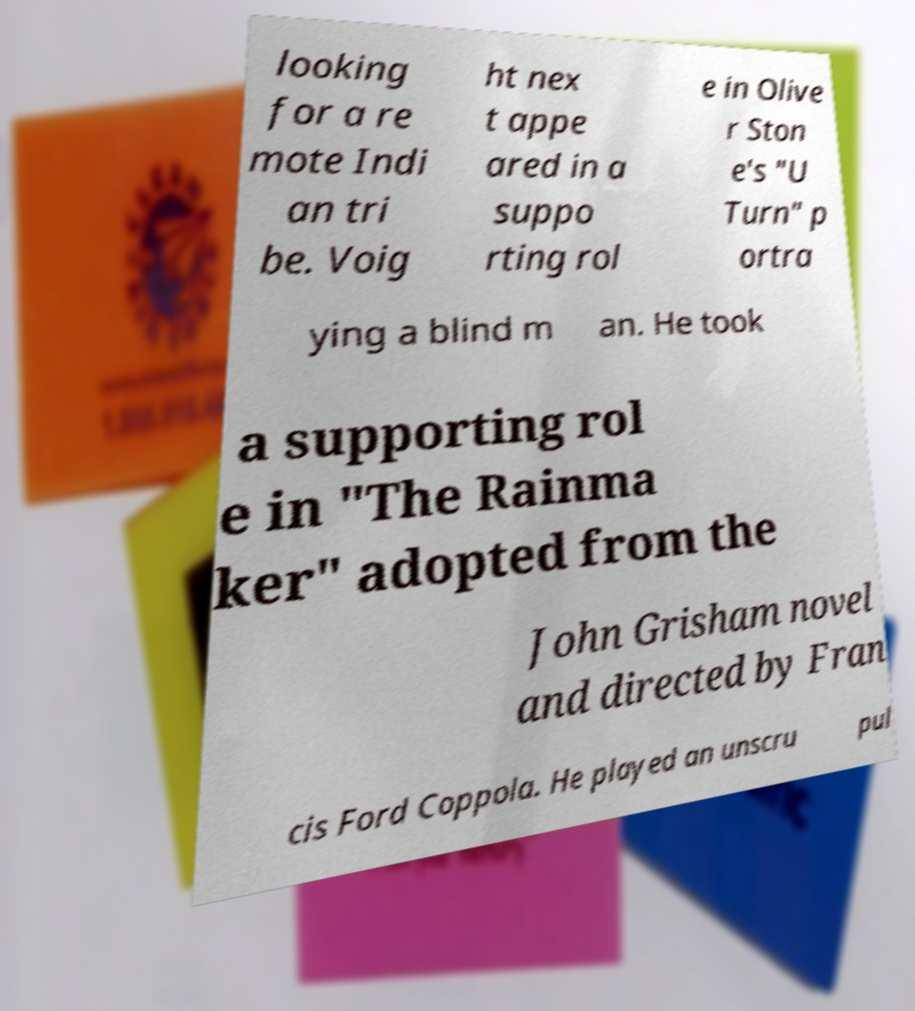Please read and relay the text visible in this image. What does it say? looking for a re mote Indi an tri be. Voig ht nex t appe ared in a suppo rting rol e in Olive r Ston e's "U Turn" p ortra ying a blind m an. He took a supporting rol e in "The Rainma ker" adopted from the John Grisham novel and directed by Fran cis Ford Coppola. He played an unscru pul 